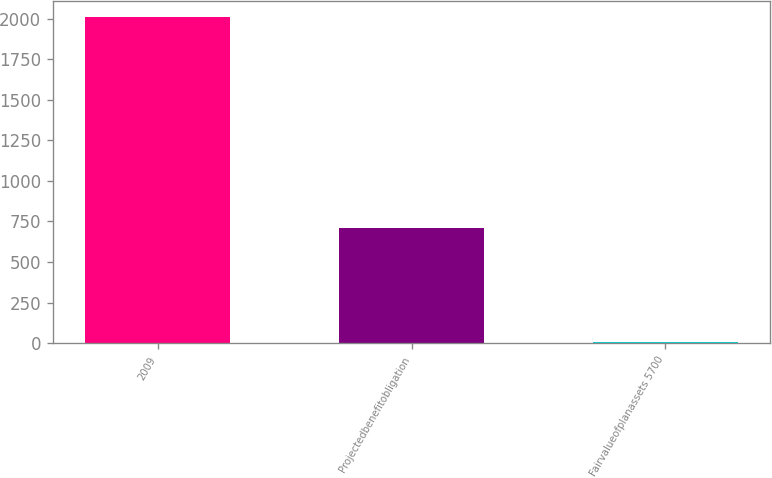<chart> <loc_0><loc_0><loc_500><loc_500><bar_chart><fcel>2009<fcel>Projectedbenefitobligation<fcel>Fairvalueofplanassets 5700<nl><fcel>2008<fcel>712<fcel>4<nl></chart> 